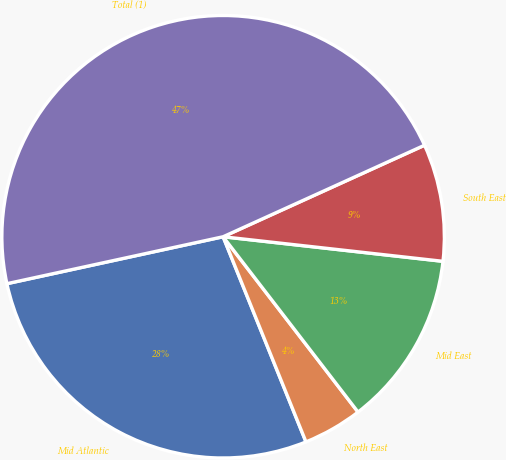<chart> <loc_0><loc_0><loc_500><loc_500><pie_chart><fcel>Mid Atlantic<fcel>North East<fcel>Mid East<fcel>South East<fcel>Total (1)<nl><fcel>27.71%<fcel>4.33%<fcel>12.79%<fcel>8.56%<fcel>46.62%<nl></chart> 